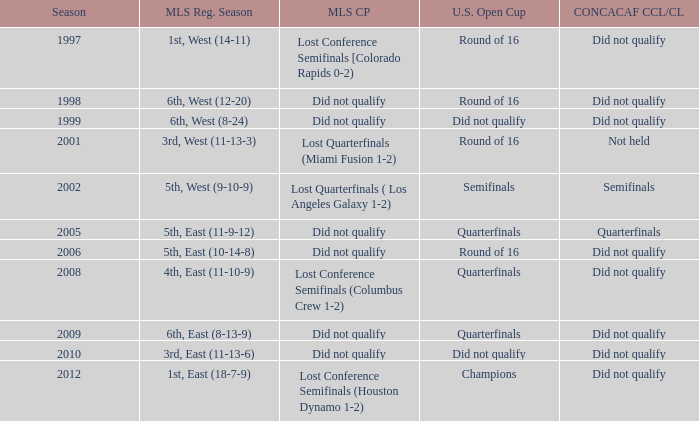When was the first season? 1997.0. Could you help me parse every detail presented in this table? {'header': ['Season', 'MLS Reg. Season', 'MLS CP', 'U.S. Open Cup', 'CONCACAF CCL/CL'], 'rows': [['1997', '1st, West (14-11)', 'Lost Conference Semifinals [Colorado Rapids 0-2)', 'Round of 16', 'Did not qualify'], ['1998', '6th, West (12-20)', 'Did not qualify', 'Round of 16', 'Did not qualify'], ['1999', '6th, West (8-24)', 'Did not qualify', 'Did not qualify', 'Did not qualify'], ['2001', '3rd, West (11-13-3)', 'Lost Quarterfinals (Miami Fusion 1-2)', 'Round of 16', 'Not held'], ['2002', '5th, West (9-10-9)', 'Lost Quarterfinals ( Los Angeles Galaxy 1-2)', 'Semifinals', 'Semifinals'], ['2005', '5th, East (11-9-12)', 'Did not qualify', 'Quarterfinals', 'Quarterfinals'], ['2006', '5th, East (10-14-8)', 'Did not qualify', 'Round of 16', 'Did not qualify'], ['2008', '4th, East (11-10-9)', 'Lost Conference Semifinals (Columbus Crew 1-2)', 'Quarterfinals', 'Did not qualify'], ['2009', '6th, East (8-13-9)', 'Did not qualify', 'Quarterfinals', 'Did not qualify'], ['2010', '3rd, East (11-13-6)', 'Did not qualify', 'Did not qualify', 'Did not qualify'], ['2012', '1st, East (18-7-9)', 'Lost Conference Semifinals (Houston Dynamo 1-2)', 'Champions', 'Did not qualify']]} 